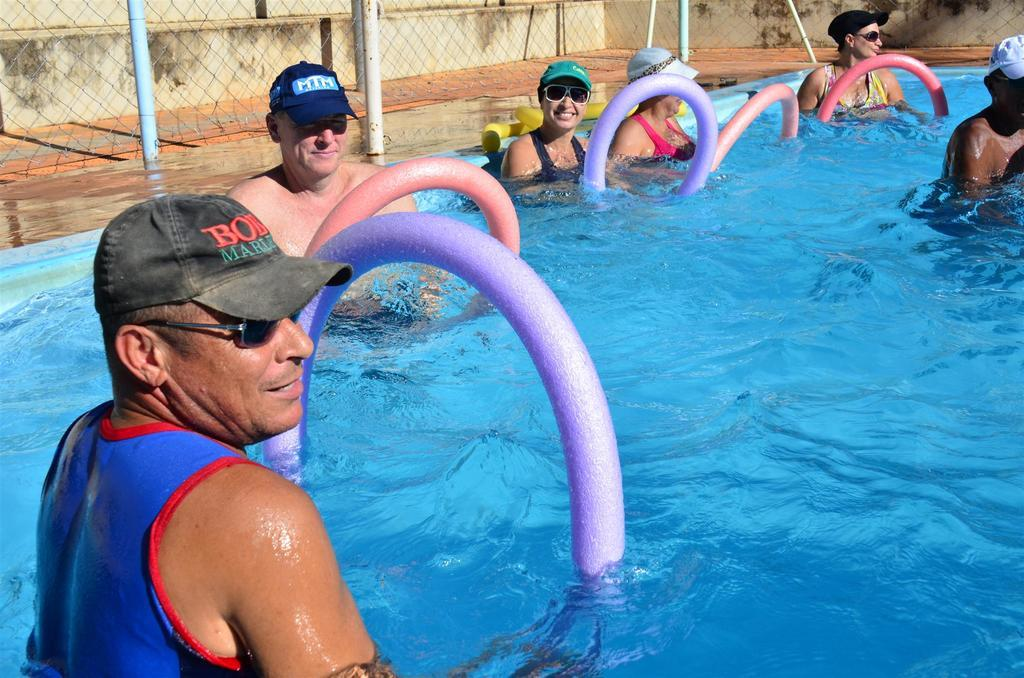What are the people in the image doing? The people in the image are in the water. What else can be seen in the water besides the people? There are colorful objects in the water. What can be seen in the background of the image? There is a fencing, poles, and a wall in the background. How many servants are present in the image? There is no mention of servants in the image, so it is not possible to determine their presence or number. 